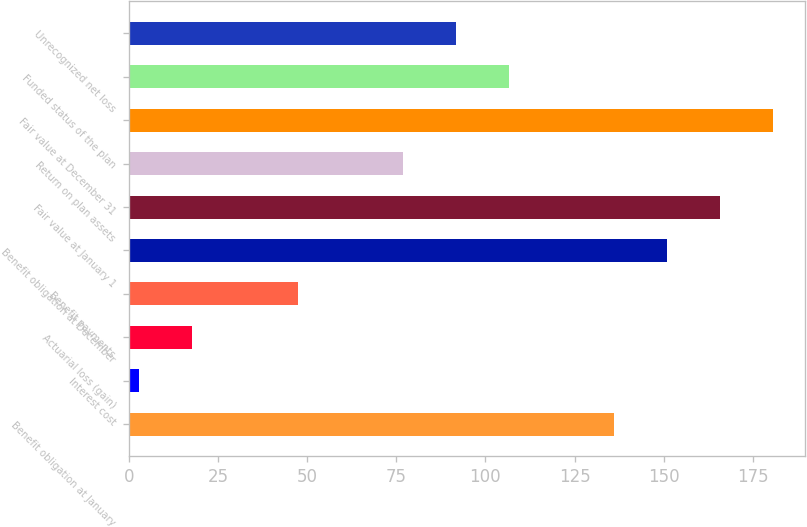<chart> <loc_0><loc_0><loc_500><loc_500><bar_chart><fcel>Benefit obligation at January<fcel>Interest cost<fcel>Actuarial loss (gain)<fcel>Benefit payments<fcel>Benefit obligation at December<fcel>Fair value at January 1<fcel>Return on plan assets<fcel>Fair value at December 31<fcel>Funded status of the plan<fcel>Unrecognized net loss<nl><fcel>136.2<fcel>3<fcel>17.8<fcel>47.4<fcel>151<fcel>165.8<fcel>77<fcel>180.6<fcel>106.6<fcel>91.8<nl></chart> 